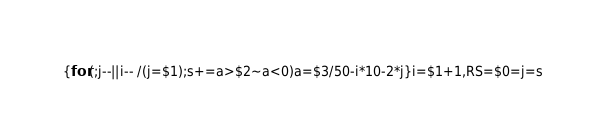Convert code to text. <code><loc_0><loc_0><loc_500><loc_500><_Awk_>{for(;j--||i-- /(j=$1);s+=a>$2~a<0)a=$3/50-i*10-2*j}i=$1+1,RS=$0=j=s</code> 